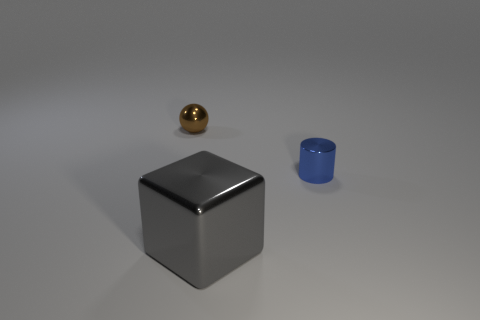Are there any other things that have the same size as the cube?
Ensure brevity in your answer.  No. Are there any other things that are the same shape as the gray metal object?
Make the answer very short. No. There is a metal object that is both right of the brown thing and behind the big object; what is its color?
Your answer should be very brief. Blue. What number of metallic cylinders are on the right side of the tiny thing to the right of the brown shiny thing?
Give a very brief answer. 0. Is there a tiny yellow matte thing of the same shape as the tiny brown metallic object?
Give a very brief answer. No. Do the object that is left of the big metallic object and the thing in front of the blue shiny cylinder have the same shape?
Ensure brevity in your answer.  No. What number of objects are cyan matte spheres or cylinders?
Offer a very short reply. 1. Is the number of tiny blue objects behind the brown sphere greater than the number of blue matte cubes?
Your answer should be very brief. No. Are the brown thing and the gray thing made of the same material?
Give a very brief answer. Yes. What number of things are either things on the left side of the big metallic object or objects that are in front of the tiny brown ball?
Your answer should be very brief. 3. 